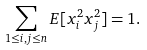<formula> <loc_0><loc_0><loc_500><loc_500>\sum _ { 1 \leq i , j \leq n } E [ x _ { i } ^ { 2 } x _ { j } ^ { 2 } ] = 1 .</formula> 